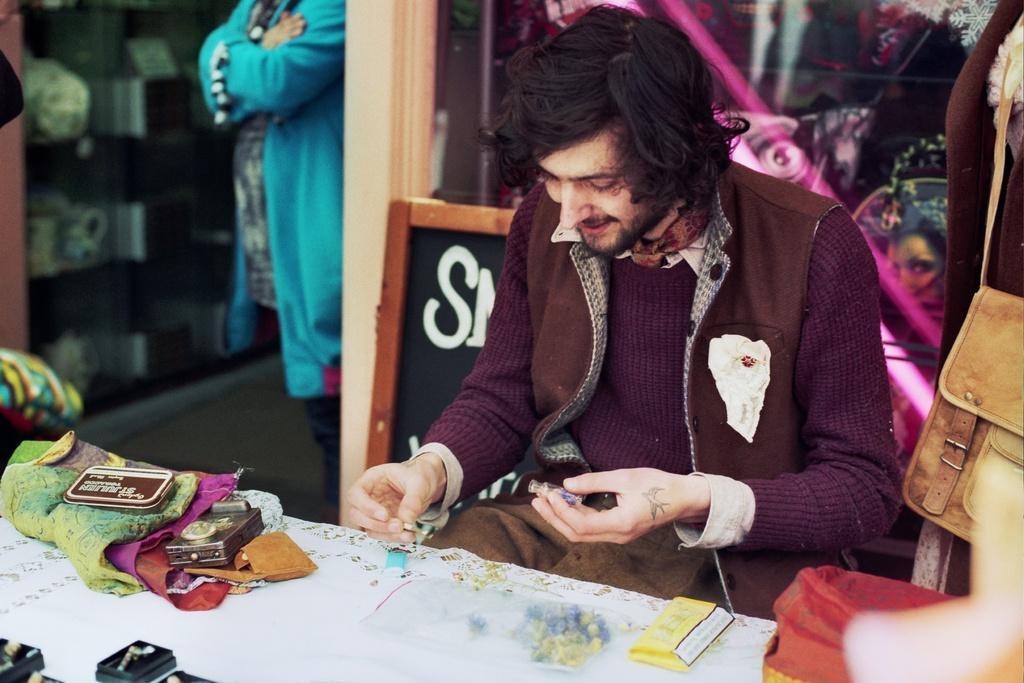Can you describe this image briefly? At the bottom of the image on the table there are boxes, clothes and some other things. Behind the table there is a man sitting and holding something in his hand. Behind him there is a board with a text on it. And also there is a glass wall. Behind the glass there are few objects. Beside the glass wall there is a person standing. On the right corner of the image there is a bag. And there is a blur background. 